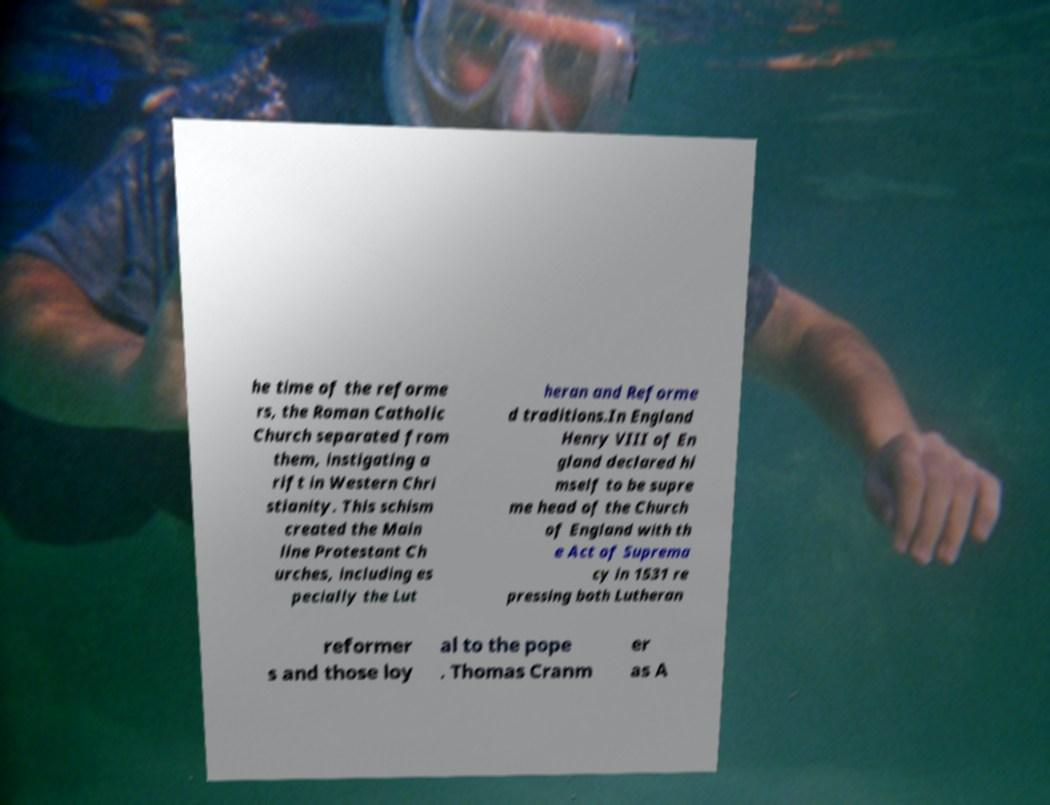I need the written content from this picture converted into text. Can you do that? he time of the reforme rs, the Roman Catholic Church separated from them, instigating a rift in Western Chri stianity. This schism created the Main line Protestant Ch urches, including es pecially the Lut heran and Reforme d traditions.In England Henry VIII of En gland declared hi mself to be supre me head of the Church of England with th e Act of Suprema cy in 1531 re pressing both Lutheran reformer s and those loy al to the pope . Thomas Cranm er as A 